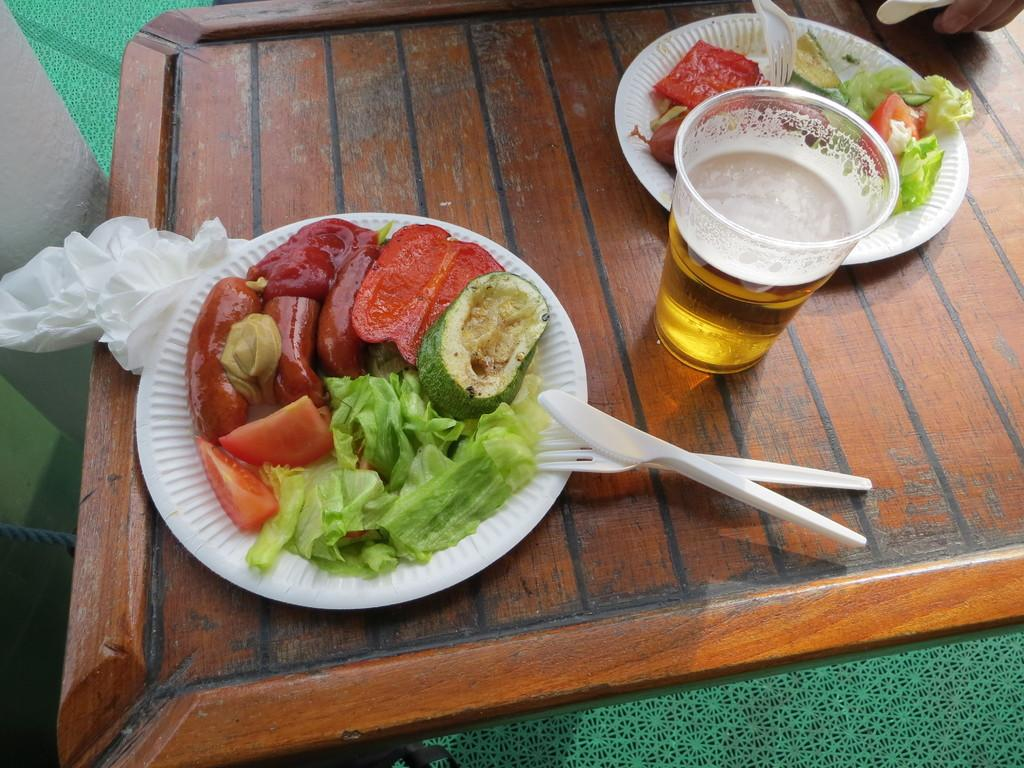What is present on the plates in the image? There are food items in the plates. What utensils can be seen in the image? A spoon and a fork are visible in the image. What is used for drinking in the image? A glass is visible in the image. What is the tray made of? The items are on a brown tray. How can you describe the appearance of the food? The food has different colors. What arithmetic problem can be solved using the calculator in the image? There is no calculator present in the image. What type of teeth can be seen in the image? There are no teeth visible in the image; it features food items on plates with utensils and a glass. 